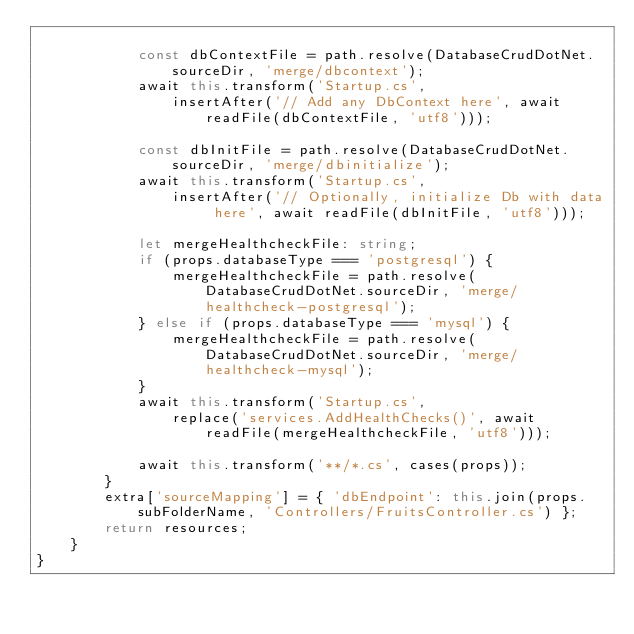<code> <loc_0><loc_0><loc_500><loc_500><_TypeScript_>
            const dbContextFile = path.resolve(DatabaseCrudDotNet.sourceDir, 'merge/dbcontext');
            await this.transform('Startup.cs',
                insertAfter('// Add any DbContext here', await readFile(dbContextFile, 'utf8')));

            const dbInitFile = path.resolve(DatabaseCrudDotNet.sourceDir, 'merge/dbinitialize');
            await this.transform('Startup.cs',
                insertAfter('// Optionally, initialize Db with data here', await readFile(dbInitFile, 'utf8')));

            let mergeHealthcheckFile: string;
            if (props.databaseType === 'postgresql') {
                mergeHealthcheckFile = path.resolve(DatabaseCrudDotNet.sourceDir, 'merge/healthcheck-postgresql');
            } else if (props.databaseType === 'mysql') {
                mergeHealthcheckFile = path.resolve(DatabaseCrudDotNet.sourceDir, 'merge/healthcheck-mysql');
            }
            await this.transform('Startup.cs',
                replace('services.AddHealthChecks()', await readFile(mergeHealthcheckFile, 'utf8')));

            await this.transform('**/*.cs', cases(props));
        }
        extra['sourceMapping'] = { 'dbEndpoint': this.join(props.subFolderName, 'Controllers/FruitsController.cs') };
        return resources;
    }
}
</code> 